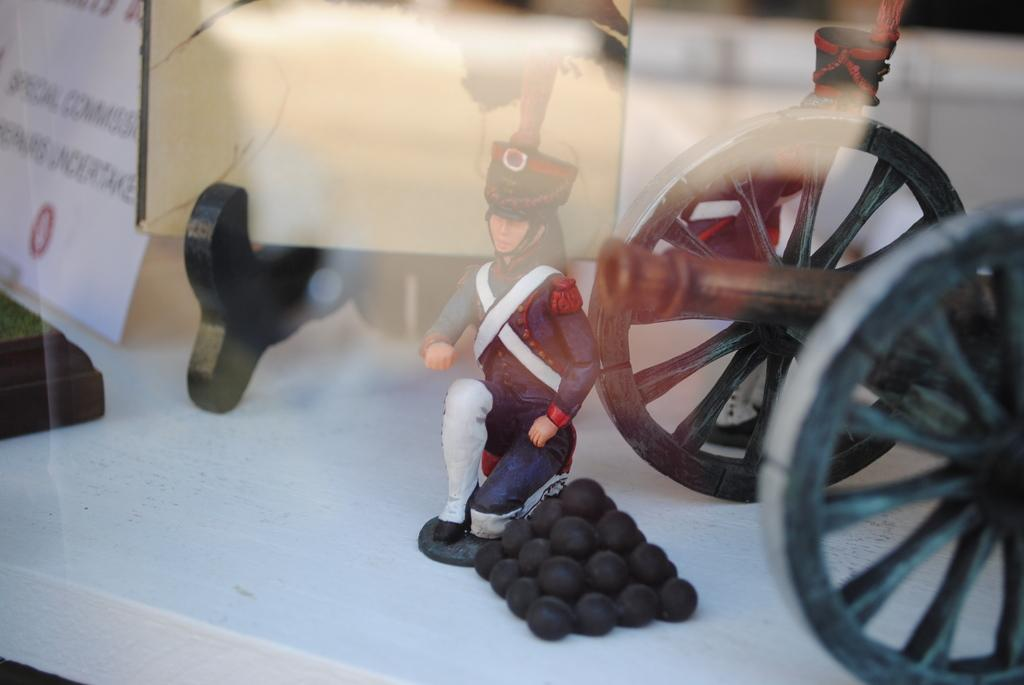What type of toy is present in the image? There is a toy person in the image. What other toy is present in the image? There is a toy cannon in the image. Are there any other toy objects in the image? Yes, there are toy bombs in the image. What is the surface on which the toys are placed? The objects are on a white surface that resembles a table. What type of trail can be seen in the image? There is no trail present in the image; it features toys on a white surface. 